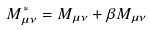<formula> <loc_0><loc_0><loc_500><loc_500>M _ { \mu \nu } ^ { \ast } = M _ { \mu \nu } + \beta M _ { \mu \nu }</formula> 